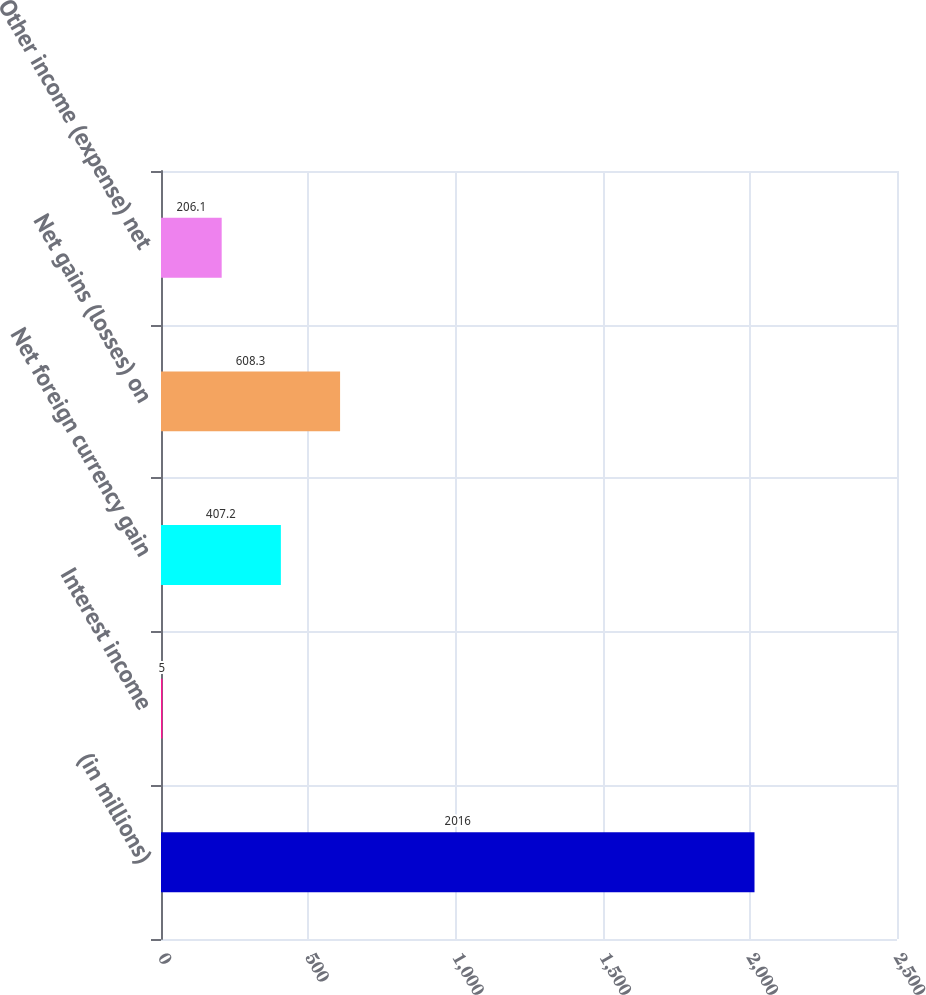Convert chart. <chart><loc_0><loc_0><loc_500><loc_500><bar_chart><fcel>(in millions)<fcel>Interest income<fcel>Net foreign currency gain<fcel>Net gains (losses) on<fcel>Other income (expense) net<nl><fcel>2016<fcel>5<fcel>407.2<fcel>608.3<fcel>206.1<nl></chart> 